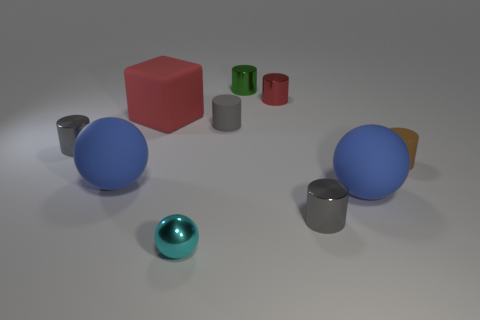How many gray cylinders must be subtracted to get 1 gray cylinders? 2 Subtract all blue cubes. How many gray cylinders are left? 3 Subtract all red shiny cylinders. How many cylinders are left? 5 Subtract all red cylinders. How many cylinders are left? 5 Subtract all yellow cylinders. Subtract all red spheres. How many cylinders are left? 6 Subtract all cubes. How many objects are left? 9 Subtract all cyan spheres. Subtract all tiny green matte spheres. How many objects are left? 9 Add 4 blue matte spheres. How many blue matte spheres are left? 6 Add 4 big matte blocks. How many big matte blocks exist? 5 Subtract 0 brown balls. How many objects are left? 10 